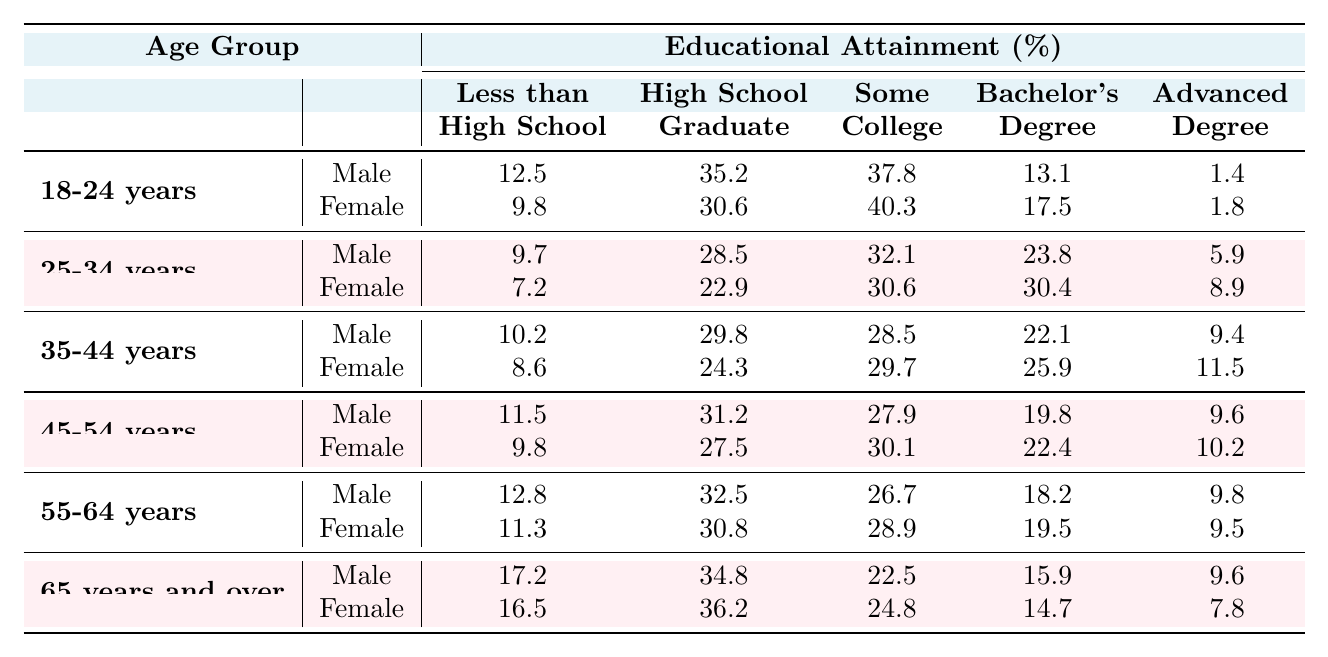What percentage of males aged 18-24 have a Bachelor's Degree? In the table, the percentage of males aged 18-24 with a Bachelor's Degree is given as 13.1%.
Answer: 13.1% Which gender has a higher percentage of 'Less than High School' education in the 55-64 age group? For the 55-64 age group, males have 12.8% and females have 11.3% for 'Less than High School', thus males have a higher percentage.
Answer: Male What is the total percentage of 'Some College' education for females aged 25-34 and 35-44 combined? For females aged 25-34, 'Some College' is 30.6%, and for 35-44, it is 29.7%. Adding these gives 30.6 + 29.7 = 60.3%.
Answer: 60.3% Is it true that a higher percentage of females than males aged 45-54 have an Advanced Degree? For females aged 45-54, the percentage for Advanced Degree is 10.2%, while for males it's 9.6%. Since 10.2 > 9.6, the statement is true.
Answer: Yes What is the difference in the percentage of males and females with 'Some College' education in the 65 years and over category? The percentage for males aged 65 and over is 22.5%, while for females, it is 24.8%. The difference is 24.8 - 22.5 = 2.3%.
Answer: 2.3% What is the average percentage of High School Graduates for both genders in the 35-44 age group? For males, it is 29.8% and for females, 24.3%. The average is (29.8 + 24.3) / 2 = 27.05%.
Answer: 27.05% Which age group has the lowest percentage of 'Less than High School' for females? By comparing the percentages, the age group 25-34 has the lowest at 7.2%.
Answer: 25-34 years What is the total percentage of graduates (Bachelor's and Advanced Degrees) for females in the 45-54 age group? The percentage of Bachelor's Degree for females is 22.4% and Advanced Degree is 10.2%. The total is 22.4 + 10.2 = 32.6%.
Answer: 32.6% In which age group is the percentage of males with a Bachelor's Degree highest? For males, the highest percentage of Bachelor's Degree is in the 25-34 age group at 23.8%.
Answer: 25-34 years 